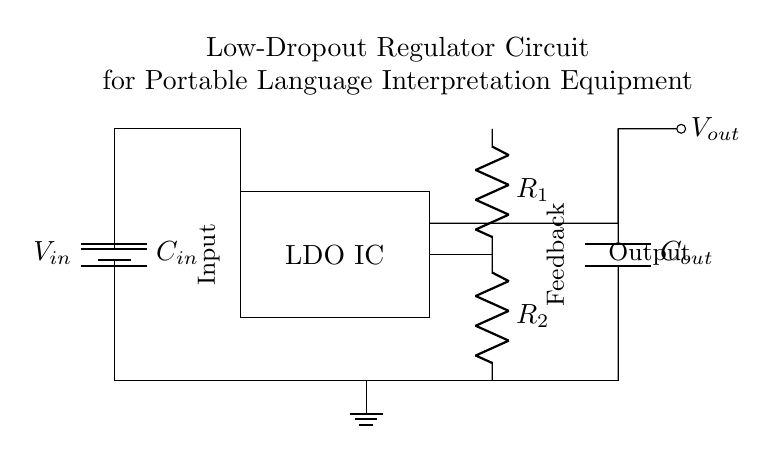What is the input voltage of the regulator? The input voltage is represented by V_in, which is connected to the battery symbol in the circuit diagram.
Answer: V_in What are the names of the capacitors in the circuit? The circuit contains two capacitors: C_in connected to the input and C_out connected to the output of the LDO IC.
Answer: C_in, C_out How many resistors are present in the feedback path? There are two resistors, R_1 and R_2, located in series in the feedback path between the output voltage and the ground.
Answer: 2 What is the function of the LDO IC? The LDO (Low-Dropout) IC regulates the output voltage V_out by maintaining a constant voltage level despite variations in the input voltage and load current.
Answer: Voltage regulation What type of circuit is shown in the diagram? This circuit is a Low-Dropout Regulator (LDO) circuit specifically designed to minimize voltage loss while regulating output voltage for use in portable language interpretation equipment.
Answer: LDO circuit What does 'V_out' represent in the circuit? 'V_out' represents the regulated output voltage available for powering the language interpretation equipment, resulting from the action of the LDO IC.
Answer: Regulated output voltage 